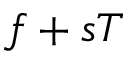<formula> <loc_0><loc_0><loc_500><loc_500>f + s T</formula> 